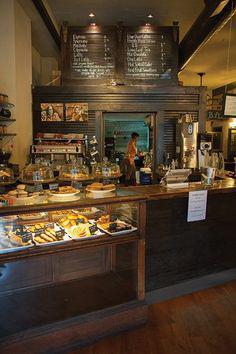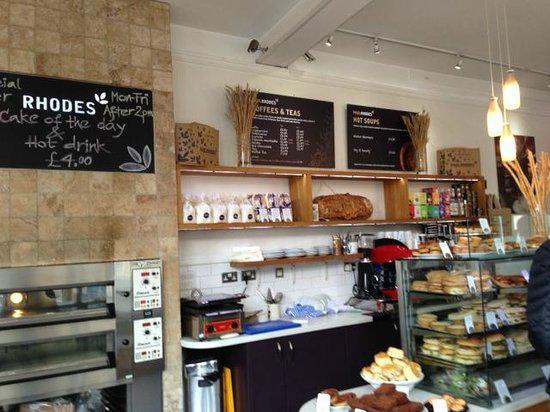The first image is the image on the left, the second image is the image on the right. Assess this claim about the two images: "In at least one image there are two bright lights focused on a coffee chalkboard.". Correct or not? Answer yes or no. Yes. The first image is the image on the left, the second image is the image on the right. Given the left and right images, does the statement "At least one person is standing at a counter and at least one person is sitting at a table with wood chairs around it in one image." hold true? Answer yes or no. No. 